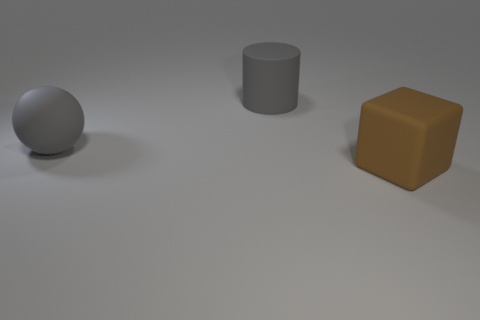Add 3 gray matte balls. How many objects exist? 6 Subtract all cylinders. How many objects are left? 2 Subtract 1 cubes. How many cubes are left? 0 Subtract all green cylinders. Subtract all brown spheres. How many cylinders are left? 1 Subtract all gray metallic cylinders. Subtract all gray rubber cylinders. How many objects are left? 2 Add 1 gray spheres. How many gray spheres are left? 2 Add 2 big gray objects. How many big gray objects exist? 4 Subtract 0 brown spheres. How many objects are left? 3 